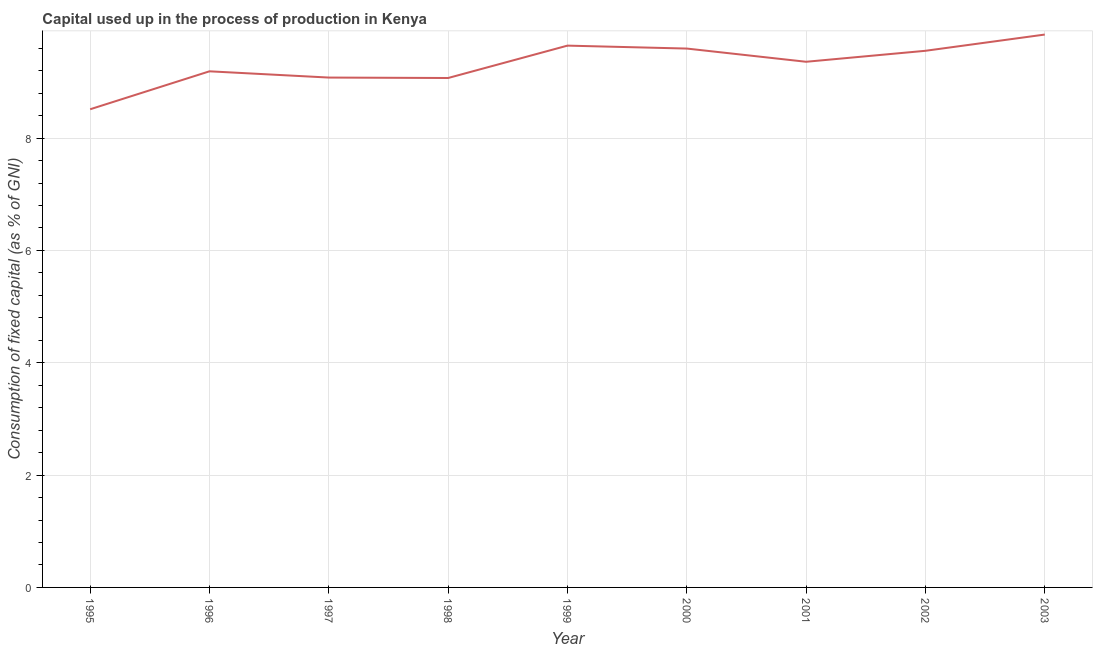What is the consumption of fixed capital in 2002?
Your answer should be compact. 9.56. Across all years, what is the maximum consumption of fixed capital?
Provide a short and direct response. 9.84. Across all years, what is the minimum consumption of fixed capital?
Ensure brevity in your answer.  8.51. In which year was the consumption of fixed capital minimum?
Keep it short and to the point. 1995. What is the sum of the consumption of fixed capital?
Give a very brief answer. 83.85. What is the difference between the consumption of fixed capital in 1997 and 2001?
Offer a very short reply. -0.28. What is the average consumption of fixed capital per year?
Make the answer very short. 9.32. What is the median consumption of fixed capital?
Provide a succinct answer. 9.36. In how many years, is the consumption of fixed capital greater than 2.8 %?
Offer a terse response. 9. What is the ratio of the consumption of fixed capital in 2000 to that in 2003?
Provide a short and direct response. 0.97. Is the consumption of fixed capital in 2000 less than that in 2001?
Give a very brief answer. No. What is the difference between the highest and the second highest consumption of fixed capital?
Your answer should be compact. 0.2. What is the difference between the highest and the lowest consumption of fixed capital?
Offer a very short reply. 1.33. In how many years, is the consumption of fixed capital greater than the average consumption of fixed capital taken over all years?
Provide a succinct answer. 5. Does the graph contain grids?
Offer a terse response. Yes. What is the title of the graph?
Offer a very short reply. Capital used up in the process of production in Kenya. What is the label or title of the Y-axis?
Provide a short and direct response. Consumption of fixed capital (as % of GNI). What is the Consumption of fixed capital (as % of GNI) of 1995?
Offer a very short reply. 8.51. What is the Consumption of fixed capital (as % of GNI) of 1996?
Keep it short and to the point. 9.19. What is the Consumption of fixed capital (as % of GNI) of 1997?
Ensure brevity in your answer.  9.08. What is the Consumption of fixed capital (as % of GNI) of 1998?
Your answer should be compact. 9.07. What is the Consumption of fixed capital (as % of GNI) of 1999?
Your answer should be compact. 9.65. What is the Consumption of fixed capital (as % of GNI) of 2000?
Keep it short and to the point. 9.59. What is the Consumption of fixed capital (as % of GNI) of 2001?
Offer a terse response. 9.36. What is the Consumption of fixed capital (as % of GNI) in 2002?
Offer a very short reply. 9.56. What is the Consumption of fixed capital (as % of GNI) of 2003?
Offer a terse response. 9.84. What is the difference between the Consumption of fixed capital (as % of GNI) in 1995 and 1996?
Keep it short and to the point. -0.68. What is the difference between the Consumption of fixed capital (as % of GNI) in 1995 and 1997?
Make the answer very short. -0.56. What is the difference between the Consumption of fixed capital (as % of GNI) in 1995 and 1998?
Your answer should be compact. -0.56. What is the difference between the Consumption of fixed capital (as % of GNI) in 1995 and 1999?
Your answer should be very brief. -1.13. What is the difference between the Consumption of fixed capital (as % of GNI) in 1995 and 2000?
Provide a short and direct response. -1.08. What is the difference between the Consumption of fixed capital (as % of GNI) in 1995 and 2001?
Offer a very short reply. -0.85. What is the difference between the Consumption of fixed capital (as % of GNI) in 1995 and 2002?
Make the answer very short. -1.04. What is the difference between the Consumption of fixed capital (as % of GNI) in 1995 and 2003?
Provide a succinct answer. -1.33. What is the difference between the Consumption of fixed capital (as % of GNI) in 1996 and 1997?
Make the answer very short. 0.11. What is the difference between the Consumption of fixed capital (as % of GNI) in 1996 and 1998?
Your answer should be compact. 0.12. What is the difference between the Consumption of fixed capital (as % of GNI) in 1996 and 1999?
Ensure brevity in your answer.  -0.46. What is the difference between the Consumption of fixed capital (as % of GNI) in 1996 and 2000?
Your response must be concise. -0.41. What is the difference between the Consumption of fixed capital (as % of GNI) in 1996 and 2001?
Provide a short and direct response. -0.17. What is the difference between the Consumption of fixed capital (as % of GNI) in 1996 and 2002?
Offer a terse response. -0.37. What is the difference between the Consumption of fixed capital (as % of GNI) in 1996 and 2003?
Give a very brief answer. -0.65. What is the difference between the Consumption of fixed capital (as % of GNI) in 1997 and 1998?
Offer a very short reply. 0.01. What is the difference between the Consumption of fixed capital (as % of GNI) in 1997 and 1999?
Ensure brevity in your answer.  -0.57. What is the difference between the Consumption of fixed capital (as % of GNI) in 1997 and 2000?
Make the answer very short. -0.52. What is the difference between the Consumption of fixed capital (as % of GNI) in 1997 and 2001?
Offer a terse response. -0.28. What is the difference between the Consumption of fixed capital (as % of GNI) in 1997 and 2002?
Keep it short and to the point. -0.48. What is the difference between the Consumption of fixed capital (as % of GNI) in 1997 and 2003?
Make the answer very short. -0.77. What is the difference between the Consumption of fixed capital (as % of GNI) in 1998 and 1999?
Your answer should be compact. -0.58. What is the difference between the Consumption of fixed capital (as % of GNI) in 1998 and 2000?
Offer a very short reply. -0.52. What is the difference between the Consumption of fixed capital (as % of GNI) in 1998 and 2001?
Your answer should be very brief. -0.29. What is the difference between the Consumption of fixed capital (as % of GNI) in 1998 and 2002?
Make the answer very short. -0.48. What is the difference between the Consumption of fixed capital (as % of GNI) in 1998 and 2003?
Provide a succinct answer. -0.77. What is the difference between the Consumption of fixed capital (as % of GNI) in 1999 and 2000?
Your answer should be very brief. 0.05. What is the difference between the Consumption of fixed capital (as % of GNI) in 1999 and 2001?
Offer a terse response. 0.29. What is the difference between the Consumption of fixed capital (as % of GNI) in 1999 and 2002?
Give a very brief answer. 0.09. What is the difference between the Consumption of fixed capital (as % of GNI) in 1999 and 2003?
Your answer should be compact. -0.2. What is the difference between the Consumption of fixed capital (as % of GNI) in 2000 and 2001?
Your response must be concise. 0.24. What is the difference between the Consumption of fixed capital (as % of GNI) in 2000 and 2002?
Provide a succinct answer. 0.04. What is the difference between the Consumption of fixed capital (as % of GNI) in 2000 and 2003?
Keep it short and to the point. -0.25. What is the difference between the Consumption of fixed capital (as % of GNI) in 2001 and 2002?
Ensure brevity in your answer.  -0.2. What is the difference between the Consumption of fixed capital (as % of GNI) in 2001 and 2003?
Offer a terse response. -0.48. What is the difference between the Consumption of fixed capital (as % of GNI) in 2002 and 2003?
Offer a very short reply. -0.29. What is the ratio of the Consumption of fixed capital (as % of GNI) in 1995 to that in 1996?
Offer a very short reply. 0.93. What is the ratio of the Consumption of fixed capital (as % of GNI) in 1995 to that in 1997?
Give a very brief answer. 0.94. What is the ratio of the Consumption of fixed capital (as % of GNI) in 1995 to that in 1998?
Provide a succinct answer. 0.94. What is the ratio of the Consumption of fixed capital (as % of GNI) in 1995 to that in 1999?
Your answer should be compact. 0.88. What is the ratio of the Consumption of fixed capital (as % of GNI) in 1995 to that in 2000?
Your response must be concise. 0.89. What is the ratio of the Consumption of fixed capital (as % of GNI) in 1995 to that in 2001?
Your response must be concise. 0.91. What is the ratio of the Consumption of fixed capital (as % of GNI) in 1995 to that in 2002?
Your answer should be very brief. 0.89. What is the ratio of the Consumption of fixed capital (as % of GNI) in 1995 to that in 2003?
Keep it short and to the point. 0.86. What is the ratio of the Consumption of fixed capital (as % of GNI) in 1996 to that in 1997?
Keep it short and to the point. 1.01. What is the ratio of the Consumption of fixed capital (as % of GNI) in 1996 to that in 1998?
Your answer should be very brief. 1.01. What is the ratio of the Consumption of fixed capital (as % of GNI) in 1996 to that in 1999?
Ensure brevity in your answer.  0.95. What is the ratio of the Consumption of fixed capital (as % of GNI) in 1996 to that in 2000?
Ensure brevity in your answer.  0.96. What is the ratio of the Consumption of fixed capital (as % of GNI) in 1996 to that in 2003?
Your answer should be very brief. 0.93. What is the ratio of the Consumption of fixed capital (as % of GNI) in 1997 to that in 1999?
Provide a succinct answer. 0.94. What is the ratio of the Consumption of fixed capital (as % of GNI) in 1997 to that in 2000?
Your response must be concise. 0.95. What is the ratio of the Consumption of fixed capital (as % of GNI) in 1997 to that in 2001?
Your answer should be compact. 0.97. What is the ratio of the Consumption of fixed capital (as % of GNI) in 1997 to that in 2003?
Your answer should be very brief. 0.92. What is the ratio of the Consumption of fixed capital (as % of GNI) in 1998 to that in 2000?
Give a very brief answer. 0.94. What is the ratio of the Consumption of fixed capital (as % of GNI) in 1998 to that in 2002?
Your answer should be very brief. 0.95. What is the ratio of the Consumption of fixed capital (as % of GNI) in 1998 to that in 2003?
Provide a succinct answer. 0.92. What is the ratio of the Consumption of fixed capital (as % of GNI) in 1999 to that in 2000?
Your answer should be very brief. 1. What is the ratio of the Consumption of fixed capital (as % of GNI) in 1999 to that in 2001?
Offer a terse response. 1.03. What is the ratio of the Consumption of fixed capital (as % of GNI) in 1999 to that in 2002?
Your answer should be compact. 1.01. What is the ratio of the Consumption of fixed capital (as % of GNI) in 1999 to that in 2003?
Give a very brief answer. 0.98. What is the ratio of the Consumption of fixed capital (as % of GNI) in 2000 to that in 2002?
Provide a short and direct response. 1. What is the ratio of the Consumption of fixed capital (as % of GNI) in 2001 to that in 2002?
Provide a short and direct response. 0.98. What is the ratio of the Consumption of fixed capital (as % of GNI) in 2001 to that in 2003?
Offer a terse response. 0.95. What is the ratio of the Consumption of fixed capital (as % of GNI) in 2002 to that in 2003?
Your response must be concise. 0.97. 